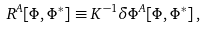Convert formula to latex. <formula><loc_0><loc_0><loc_500><loc_500>R ^ { A } [ \Phi , \Phi ^ { * } ] \equiv K ^ { - 1 } \delta \Phi ^ { A } [ \Phi , \Phi ^ { * } ] \, ,</formula> 